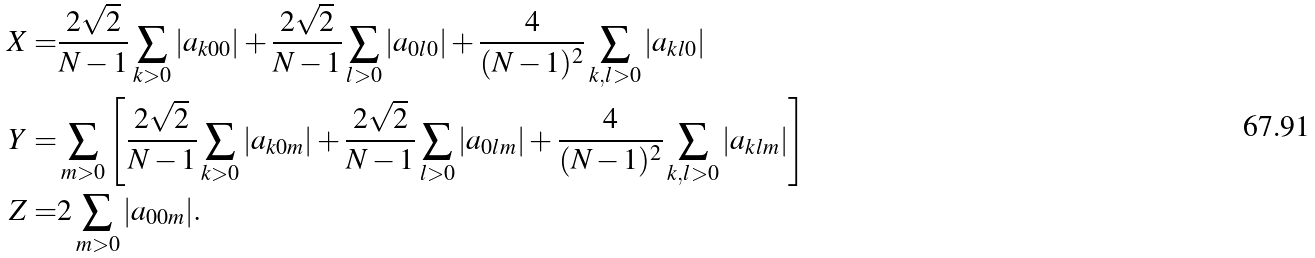<formula> <loc_0><loc_0><loc_500><loc_500>X = & \frac { 2 \sqrt { 2 } } { N - 1 } \sum _ { k > 0 } | a _ { k 0 0 } | + \frac { 2 \sqrt { 2 } } { N - 1 } \sum _ { l > 0 } | a _ { 0 l 0 } | + \frac { 4 } { ( N - 1 ) ^ { 2 } } \sum _ { k , l > 0 } | a _ { k l 0 } | \\ Y = & \sum _ { m > 0 } \left [ \frac { 2 \sqrt { 2 } } { N - 1 } \sum _ { k > 0 } | a _ { k 0 m } | + \frac { 2 \sqrt { 2 } } { N - 1 } \sum _ { l > 0 } | a _ { 0 l m } | + \frac { 4 } { ( N - 1 ) ^ { 2 } } \sum _ { k , l > 0 } | a _ { k l m } | \right ] \\ Z = & 2 \sum _ { m > 0 } | a _ { 0 0 m } | .</formula> 